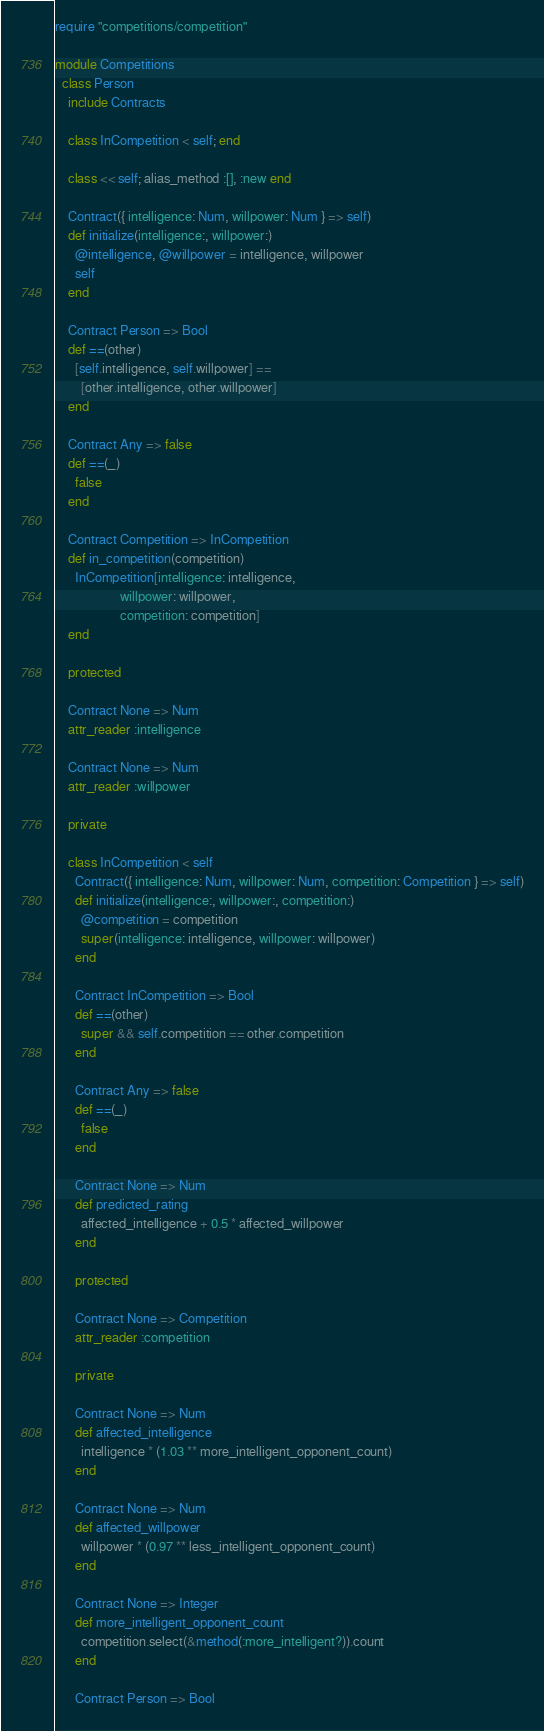Convert code to text. <code><loc_0><loc_0><loc_500><loc_500><_Ruby_>require "competitions/competition"

module Competitions
  class Person
    include Contracts

    class InCompetition < self; end

    class << self; alias_method :[], :new end

    Contract({ intelligence: Num, willpower: Num } => self)
    def initialize(intelligence:, willpower:)
      @intelligence, @willpower = intelligence, willpower
      self
    end

    Contract Person => Bool
    def ==(other)
      [self.intelligence, self.willpower] ==
        [other.intelligence, other.willpower]
    end

    Contract Any => false
    def ==(_)
      false
    end

    Contract Competition => InCompetition
    def in_competition(competition)
      InCompetition[intelligence: intelligence,
                    willpower: willpower,
                    competition: competition]
    end

    protected

    Contract None => Num
    attr_reader :intelligence

    Contract None => Num
    attr_reader :willpower

    private

    class InCompetition < self
      Contract({ intelligence: Num, willpower: Num, competition: Competition } => self)
      def initialize(intelligence:, willpower:, competition:)
        @competition = competition
        super(intelligence: intelligence, willpower: willpower)
      end

      Contract InCompetition => Bool
      def ==(other)
        super && self.competition == other.competition
      end

      Contract Any => false
      def ==(_)
        false
      end

      Contract None => Num
      def predicted_rating
        affected_intelligence + 0.5 * affected_willpower
      end

      protected

      Contract None => Competition
      attr_reader :competition

      private

      Contract None => Num
      def affected_intelligence
        intelligence * (1.03 ** more_intelligent_opponent_count)
      end

      Contract None => Num
      def affected_willpower
        willpower * (0.97 ** less_intelligent_opponent_count)
      end

      Contract None => Integer
      def more_intelligent_opponent_count
        competition.select(&method(:more_intelligent?)).count
      end

      Contract Person => Bool</code> 